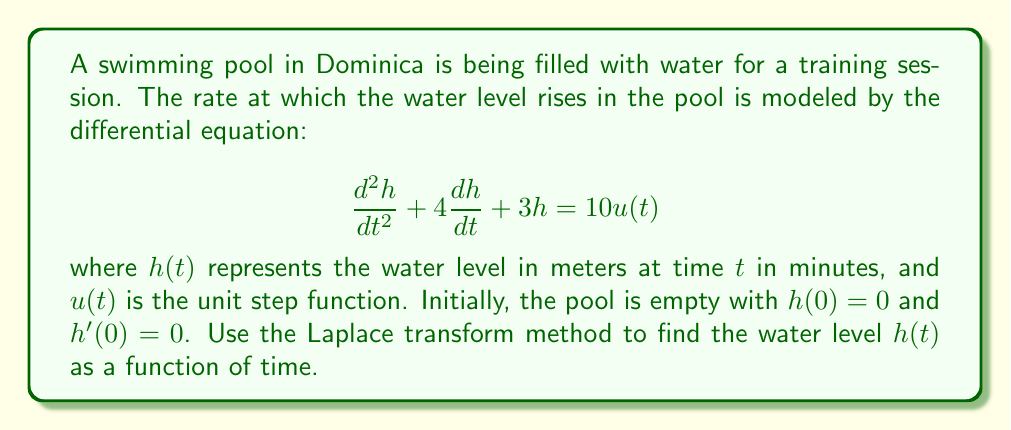Could you help me with this problem? Let's solve this problem step by step using the Laplace transform method:

1) First, let's take the Laplace transform of both sides of the equation. Let $H(s)$ be the Laplace transform of $h(t)$:

   $$\mathcal{L}\{h''(t)\} + 4\mathcal{L}\{h'(t)\} + 3\mathcal{L}\{h(t)\} = 10\mathcal{L}\{u(t)\}$$

2) Using the Laplace transform properties:

   $$s^2H(s) - sh(0) - h'(0) + 4[sH(s) - h(0)] + 3H(s) = \frac{10}{s}$$

3) Substituting the initial conditions $h(0) = 0$ and $h'(0) = 0$:

   $$s^2H(s) + 4sH(s) + 3H(s) = \frac{10}{s}$$

4) Factoring out $H(s)$:

   $$H(s)(s^2 + 4s + 3) = \frac{10}{s}$$

5) Solving for $H(s)$:

   $$H(s) = \frac{10}{s(s^2 + 4s + 3)} = \frac{10}{s(s+1)(s+3)}$$

6) Using partial fraction decomposition:

   $$H(s) = \frac{A}{s} + \frac{B}{s+1} + \frac{C}{s+3}$$

   where $A$, $B$, and $C$ are constants to be determined.

7) After solving the system of equations, we get:

   $$H(s) = \frac{10/3}{s} - \frac{5/3}{s+1} - \frac{5/3}{s+3}$$

8) Taking the inverse Laplace transform:

   $$h(t) = \frac{10}{3} - \frac{5}{3}e^{-t} - \frac{5}{3}e^{-3t}$$

This gives us the water level $h(t)$ as a function of time $t$.
Answer: $$h(t) = \frac{10}{3} - \frac{5}{3}e^{-t} - \frac{5}{3}e^{-3t}$$ 